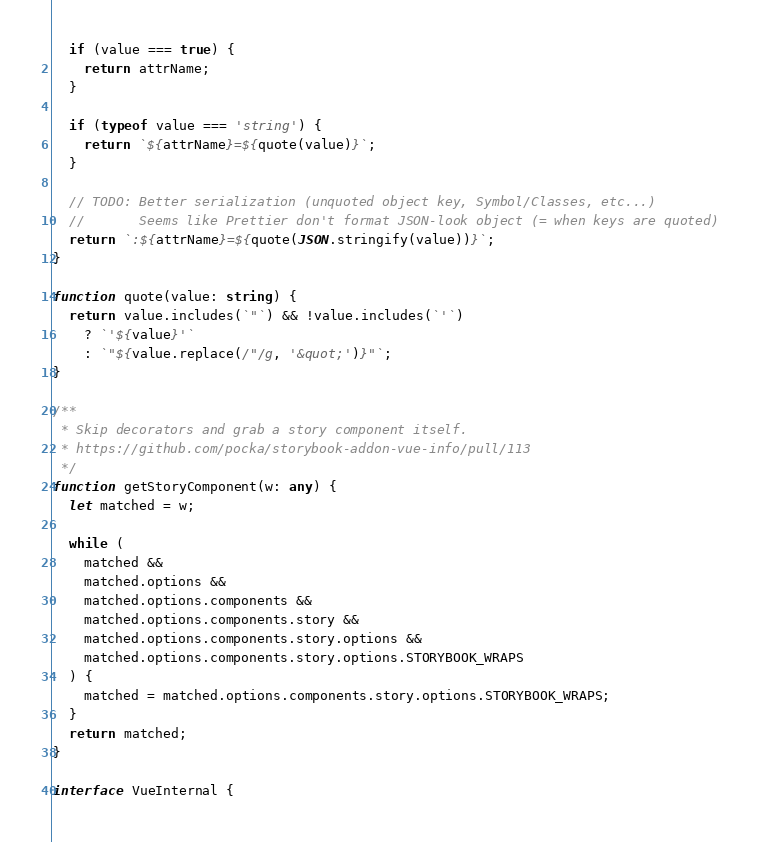<code> <loc_0><loc_0><loc_500><loc_500><_TypeScript_>
  if (value === true) {
    return attrName;
  }

  if (typeof value === 'string') {
    return `${attrName}=${quote(value)}`;
  }

  // TODO: Better serialization (unquoted object key, Symbol/Classes, etc...)
  //       Seems like Prettier don't format JSON-look object (= when keys are quoted)
  return `:${attrName}=${quote(JSON.stringify(value))}`;
}

function quote(value: string) {
  return value.includes(`"`) && !value.includes(`'`)
    ? `'${value}'`
    : `"${value.replace(/"/g, '&quot;')}"`;
}

/**
 * Skip decorators and grab a story component itself.
 * https://github.com/pocka/storybook-addon-vue-info/pull/113
 */
function getStoryComponent(w: any) {
  let matched = w;

  while (
    matched &&
    matched.options &&
    matched.options.components &&
    matched.options.components.story &&
    matched.options.components.story.options &&
    matched.options.components.story.options.STORYBOOK_WRAPS
  ) {
    matched = matched.options.components.story.options.STORYBOOK_WRAPS;
  }
  return matched;
}

interface VueInternal {</code> 